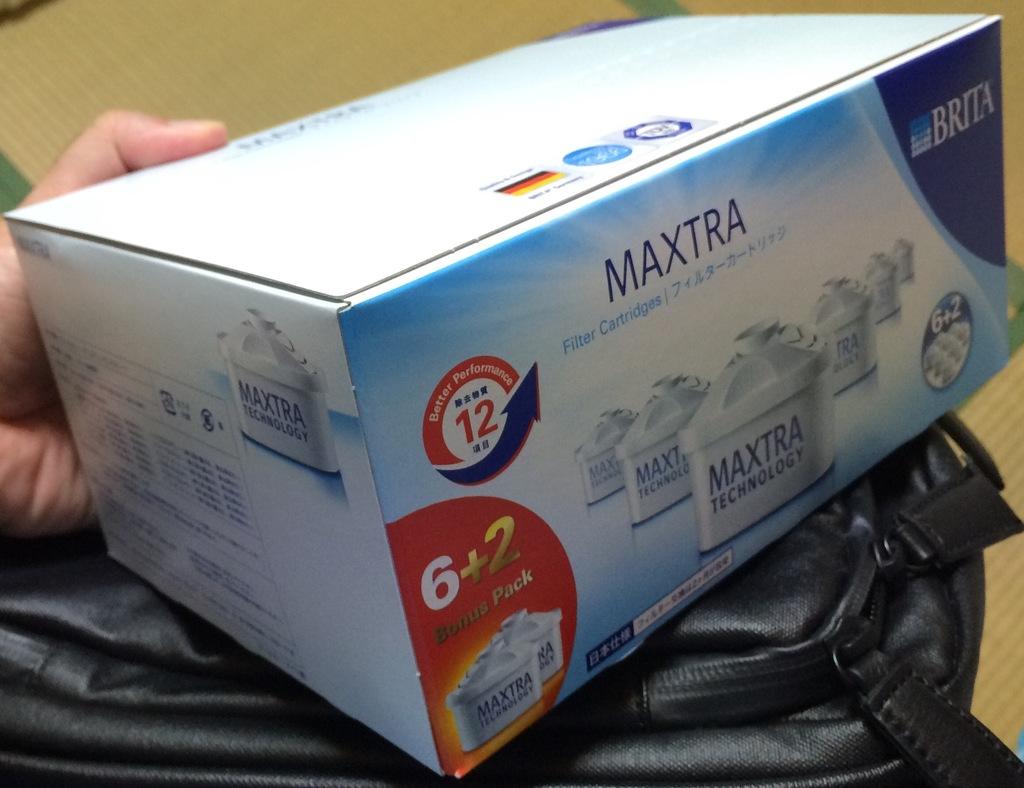How many extra products are included than normal in the box?
Your response must be concise. 2. What is the company that makes this product?
Offer a very short reply. Brita. 